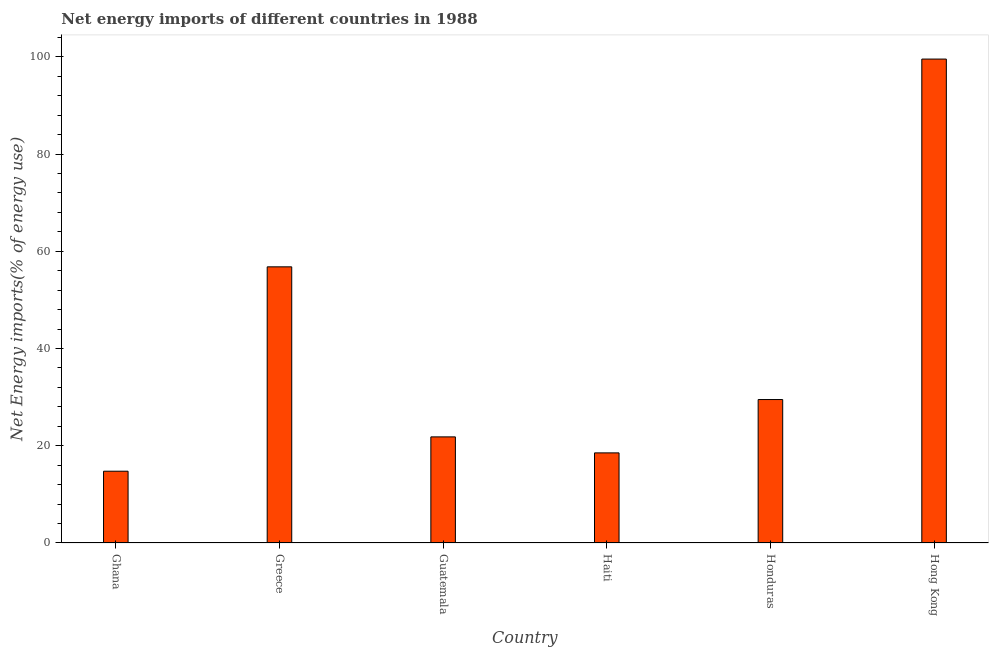Does the graph contain any zero values?
Offer a very short reply. No. What is the title of the graph?
Make the answer very short. Net energy imports of different countries in 1988. What is the label or title of the Y-axis?
Make the answer very short. Net Energy imports(% of energy use). What is the energy imports in Guatemala?
Make the answer very short. 21.82. Across all countries, what is the maximum energy imports?
Offer a terse response. 99.53. Across all countries, what is the minimum energy imports?
Your response must be concise. 14.76. In which country was the energy imports maximum?
Provide a succinct answer. Hong Kong. What is the sum of the energy imports?
Offer a terse response. 240.95. What is the difference between the energy imports in Ghana and Hong Kong?
Ensure brevity in your answer.  -84.77. What is the average energy imports per country?
Offer a terse response. 40.16. What is the median energy imports?
Offer a very short reply. 25.66. What is the ratio of the energy imports in Greece to that in Honduras?
Your answer should be compact. 1.93. Is the difference between the energy imports in Guatemala and Haiti greater than the difference between any two countries?
Keep it short and to the point. No. What is the difference between the highest and the second highest energy imports?
Keep it short and to the point. 42.73. What is the difference between the highest and the lowest energy imports?
Provide a succinct answer. 84.77. In how many countries, is the energy imports greater than the average energy imports taken over all countries?
Ensure brevity in your answer.  2. How many bars are there?
Offer a very short reply. 6. Are all the bars in the graph horizontal?
Provide a succinct answer. No. What is the difference between two consecutive major ticks on the Y-axis?
Your answer should be compact. 20. Are the values on the major ticks of Y-axis written in scientific E-notation?
Keep it short and to the point. No. What is the Net Energy imports(% of energy use) of Ghana?
Offer a terse response. 14.76. What is the Net Energy imports(% of energy use) in Greece?
Make the answer very short. 56.8. What is the Net Energy imports(% of energy use) in Guatemala?
Give a very brief answer. 21.82. What is the Net Energy imports(% of energy use) of Haiti?
Offer a very short reply. 18.53. What is the Net Energy imports(% of energy use) of Honduras?
Offer a terse response. 29.5. What is the Net Energy imports(% of energy use) of Hong Kong?
Your answer should be compact. 99.53. What is the difference between the Net Energy imports(% of energy use) in Ghana and Greece?
Offer a very short reply. -42.04. What is the difference between the Net Energy imports(% of energy use) in Ghana and Guatemala?
Your response must be concise. -7.06. What is the difference between the Net Energy imports(% of energy use) in Ghana and Haiti?
Provide a short and direct response. -3.77. What is the difference between the Net Energy imports(% of energy use) in Ghana and Honduras?
Offer a very short reply. -14.74. What is the difference between the Net Energy imports(% of energy use) in Ghana and Hong Kong?
Keep it short and to the point. -84.77. What is the difference between the Net Energy imports(% of energy use) in Greece and Guatemala?
Your answer should be very brief. 34.98. What is the difference between the Net Energy imports(% of energy use) in Greece and Haiti?
Your answer should be compact. 38.27. What is the difference between the Net Energy imports(% of energy use) in Greece and Honduras?
Keep it short and to the point. 27.3. What is the difference between the Net Energy imports(% of energy use) in Greece and Hong Kong?
Your answer should be compact. -42.73. What is the difference between the Net Energy imports(% of energy use) in Guatemala and Haiti?
Your answer should be very brief. 3.29. What is the difference between the Net Energy imports(% of energy use) in Guatemala and Honduras?
Provide a succinct answer. -7.68. What is the difference between the Net Energy imports(% of energy use) in Guatemala and Hong Kong?
Provide a short and direct response. -77.71. What is the difference between the Net Energy imports(% of energy use) in Haiti and Honduras?
Ensure brevity in your answer.  -10.97. What is the difference between the Net Energy imports(% of energy use) in Haiti and Hong Kong?
Your answer should be very brief. -81. What is the difference between the Net Energy imports(% of energy use) in Honduras and Hong Kong?
Ensure brevity in your answer.  -70.03. What is the ratio of the Net Energy imports(% of energy use) in Ghana to that in Greece?
Provide a short and direct response. 0.26. What is the ratio of the Net Energy imports(% of energy use) in Ghana to that in Guatemala?
Give a very brief answer. 0.68. What is the ratio of the Net Energy imports(% of energy use) in Ghana to that in Haiti?
Provide a short and direct response. 0.8. What is the ratio of the Net Energy imports(% of energy use) in Ghana to that in Hong Kong?
Provide a short and direct response. 0.15. What is the ratio of the Net Energy imports(% of energy use) in Greece to that in Guatemala?
Your answer should be very brief. 2.6. What is the ratio of the Net Energy imports(% of energy use) in Greece to that in Haiti?
Your response must be concise. 3.06. What is the ratio of the Net Energy imports(% of energy use) in Greece to that in Honduras?
Keep it short and to the point. 1.93. What is the ratio of the Net Energy imports(% of energy use) in Greece to that in Hong Kong?
Your answer should be very brief. 0.57. What is the ratio of the Net Energy imports(% of energy use) in Guatemala to that in Haiti?
Your response must be concise. 1.18. What is the ratio of the Net Energy imports(% of energy use) in Guatemala to that in Honduras?
Offer a very short reply. 0.74. What is the ratio of the Net Energy imports(% of energy use) in Guatemala to that in Hong Kong?
Provide a short and direct response. 0.22. What is the ratio of the Net Energy imports(% of energy use) in Haiti to that in Honduras?
Offer a very short reply. 0.63. What is the ratio of the Net Energy imports(% of energy use) in Haiti to that in Hong Kong?
Offer a very short reply. 0.19. What is the ratio of the Net Energy imports(% of energy use) in Honduras to that in Hong Kong?
Offer a very short reply. 0.3. 